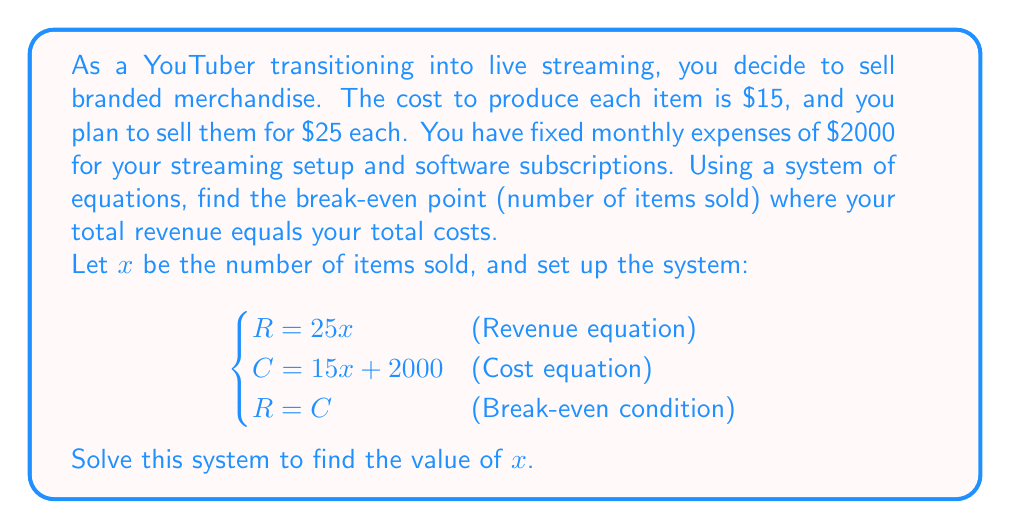Provide a solution to this math problem. To solve this problem, we'll follow these steps:

1) First, let's write out our system of equations:
   $$\begin{cases}
   R = 25x\\
   C = 15x + 2000\\
   R = C
   \end{cases}$$

2) Since R = C at the break-even point, we can substitute the equations for R and C:
   $$25x = 15x + 2000$$

3) Now we have a single equation to solve. Let's solve for x:
   $$25x - 15x = 2000$$
   $$10x = 2000$$

4) Divide both sides by 10:
   $$x = 200$$

5) To verify, let's plug this value back into our original equations:
   Revenue: $R = 25(200) = 5000$
   Cost: $C = 15(200) + 2000 = 3000 + 2000 = 5000$

   Indeed, Revenue = Cost = $5000, confirming our break-even point.

This means you need to sell 200 items to break even, covering both your variable costs (production) and fixed costs (streaming setup and subscriptions).
Answer: The break-even point is 200 items. 